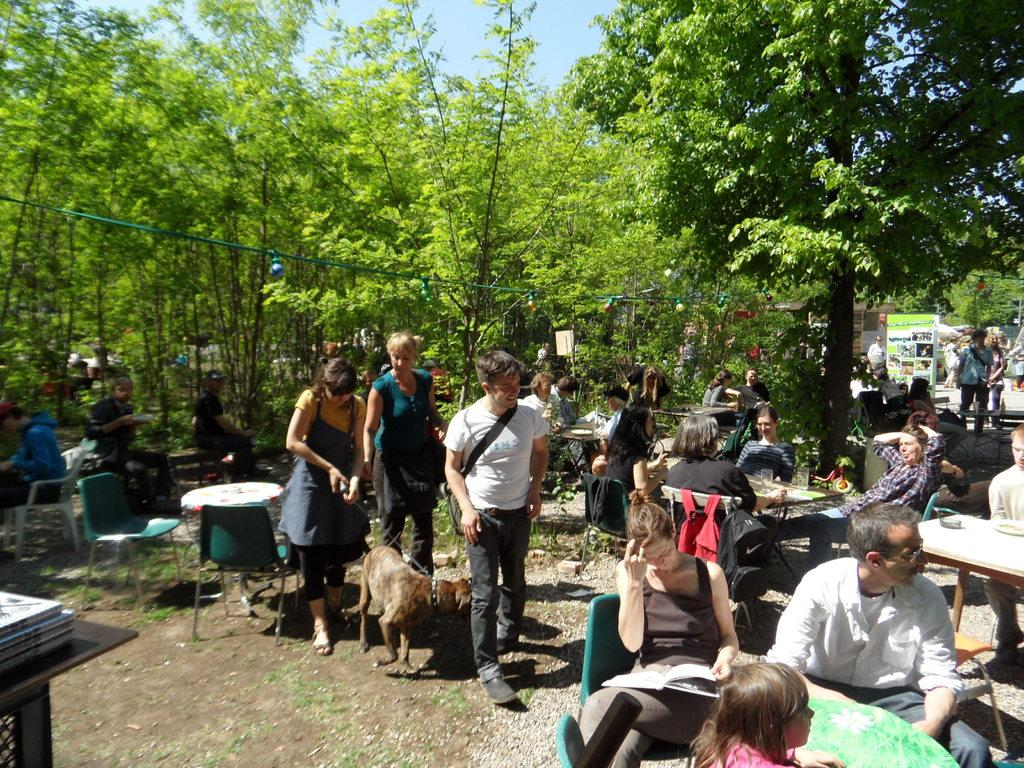What type of vegetation can be seen in the image? There are trees in the image. What are the people in the image doing? The people in the image are sitting and standing. What animal is present in the image? There is a dog in the image. What objects are on the tables in the image? There are glasses on the tables in the image. What color is the crayon used by the people in the image? There is no crayon present in the image. How does the level of the tables affect the stability of the glasses in the image? The level of the tables is not mentioned in the facts, and therefore we cannot determine its effect on the stability of the glasses. 